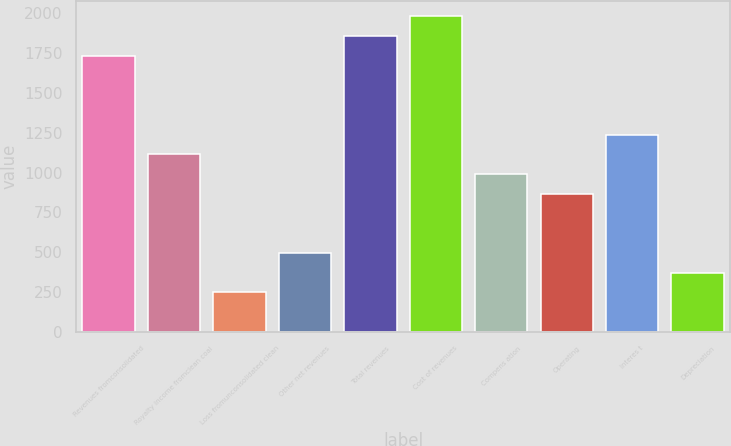Convert chart to OTSL. <chart><loc_0><loc_0><loc_500><loc_500><bar_chart><fcel>Revenues fromconsolidated<fcel>Royalty income fromclean coal<fcel>Loss fromunconsolidated clean<fcel>Other net revenues<fcel>Total revenues<fcel>Cost of revenues<fcel>Compens ation<fcel>Operating<fcel>Interes t<fcel>Depreciation<nl><fcel>1734.05<fcel>1114.75<fcel>247.73<fcel>495.45<fcel>1857.91<fcel>1981.77<fcel>990.89<fcel>867.03<fcel>1238.61<fcel>371.59<nl></chart> 